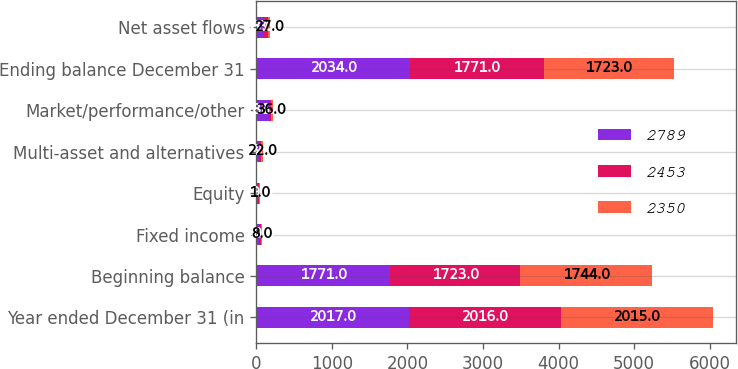<chart> <loc_0><loc_0><loc_500><loc_500><stacked_bar_chart><ecel><fcel>Year ended December 31 (in<fcel>Beginning balance<fcel>Fixed income<fcel>Equity<fcel>Multi-asset and alternatives<fcel>Market/performance/other<fcel>Ending balance December 31<fcel>Net asset flows<nl><fcel>2789<fcel>2017<fcel>1771<fcel>36<fcel>11<fcel>43<fcel>186<fcel>2034<fcel>93<nl><fcel>2453<fcel>2016<fcel>1723<fcel>30<fcel>29<fcel>22<fcel>1<fcel>1771<fcel>63<nl><fcel>2350<fcel>2015<fcel>1744<fcel>8<fcel>1<fcel>22<fcel>36<fcel>1723<fcel>27<nl></chart> 